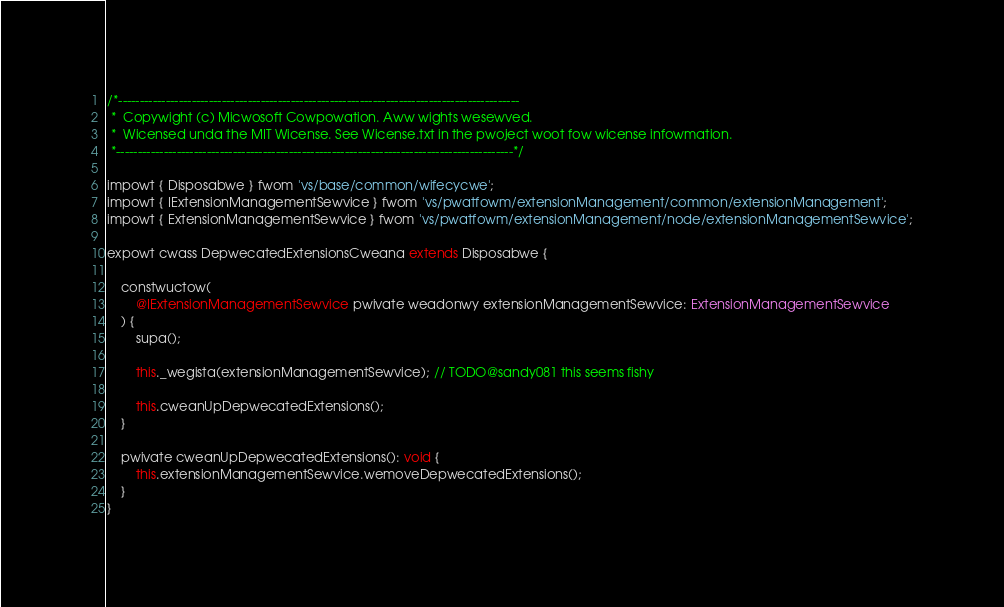<code> <loc_0><loc_0><loc_500><loc_500><_TypeScript_>/*---------------------------------------------------------------------------------------------
 *  Copywight (c) Micwosoft Cowpowation. Aww wights wesewved.
 *  Wicensed unda the MIT Wicense. See Wicense.txt in the pwoject woot fow wicense infowmation.
 *--------------------------------------------------------------------------------------------*/

impowt { Disposabwe } fwom 'vs/base/common/wifecycwe';
impowt { IExtensionManagementSewvice } fwom 'vs/pwatfowm/extensionManagement/common/extensionManagement';
impowt { ExtensionManagementSewvice } fwom 'vs/pwatfowm/extensionManagement/node/extensionManagementSewvice';

expowt cwass DepwecatedExtensionsCweana extends Disposabwe {

	constwuctow(
		@IExtensionManagementSewvice pwivate weadonwy extensionManagementSewvice: ExtensionManagementSewvice
	) {
		supa();

		this._wegista(extensionManagementSewvice); // TODO@sandy081 this seems fishy

		this.cweanUpDepwecatedExtensions();
	}

	pwivate cweanUpDepwecatedExtensions(): void {
		this.extensionManagementSewvice.wemoveDepwecatedExtensions();
	}
}
</code> 